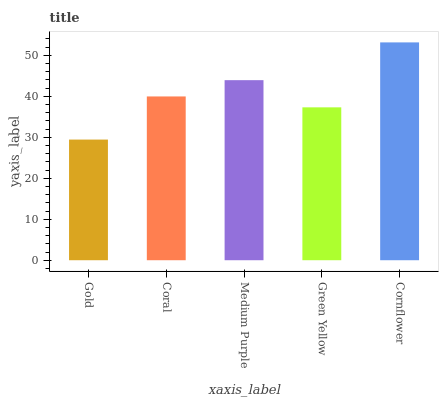Is Gold the minimum?
Answer yes or no. Yes. Is Cornflower the maximum?
Answer yes or no. Yes. Is Coral the minimum?
Answer yes or no. No. Is Coral the maximum?
Answer yes or no. No. Is Coral greater than Gold?
Answer yes or no. Yes. Is Gold less than Coral?
Answer yes or no. Yes. Is Gold greater than Coral?
Answer yes or no. No. Is Coral less than Gold?
Answer yes or no. No. Is Coral the high median?
Answer yes or no. Yes. Is Coral the low median?
Answer yes or no. Yes. Is Cornflower the high median?
Answer yes or no. No. Is Gold the low median?
Answer yes or no. No. 